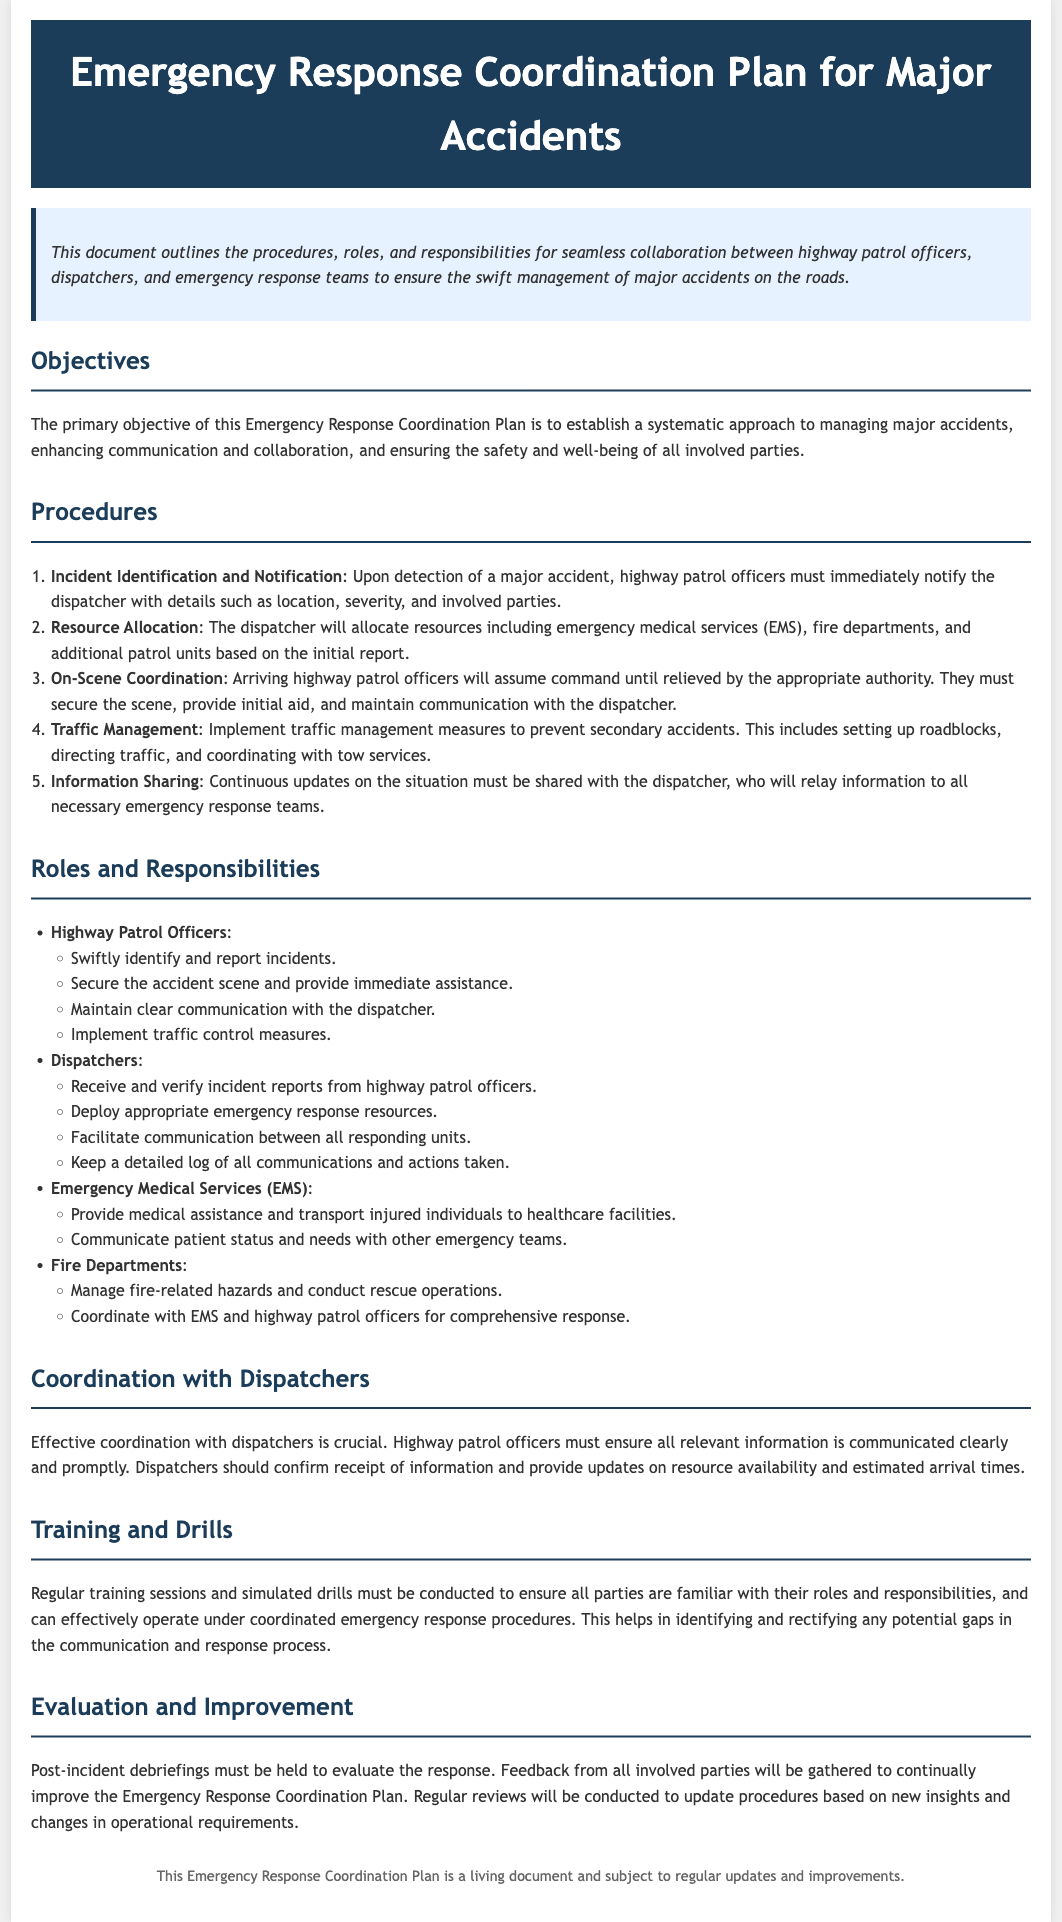What is the primary objective of the Emergency Response Coordination Plan? The primary objective is to establish a systematic approach to managing major accidents, enhancing communication and collaboration, and ensuring safety.
Answer: Establish a systematic approach What is the first procedure listed in the response plan? The first procedure is about incident identification and notification after detecting a major accident.
Answer: Incident Identification and Notification Who must maintain communication with the dispatcher? The highway patrol officers are responsible for maintaining communication with the dispatcher during an incident.
Answer: Highway Patrol Officers What kind of drills must be conducted regularly? Regular training sessions and simulated drills must be conducted for all parties to familiarize themselves with their roles.
Answer: Training sessions and simulated drills Which department is tasked with managing fire-related hazards? The fire departments are responsible for managing fire-related hazards and conducting rescue operations.
Answer: Fire Departments How many responsibilities are outlined for dispatchers? There are four responsibilities listed for dispatchers in the document.
Answer: Four What document type does this declaration exemplify? This document exemplifies an Emergency Response Coordination Plan.
Answer: Emergency Response Coordination Plan What is the method for gathering feedback post-incident? Post-incident debriefings will be held to gather feedback from all involved parties.
Answer: Post-incident debriefings What is emphasized for effective coordination with dispatchers? Effective communication and confirmation of receipt of information are emphasized for coordination.
Answer: Effective communication What must be included in the continuous updates shared with the dispatcher? Continuous updates must include the situation status and any relevant changes.
Answer: Situation status and changes 